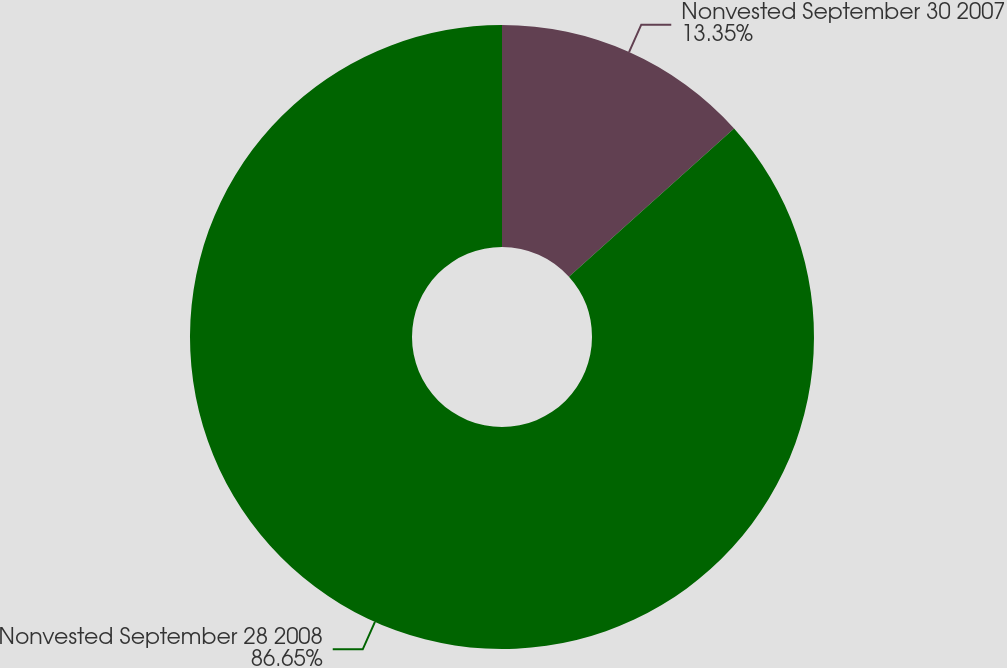Convert chart to OTSL. <chart><loc_0><loc_0><loc_500><loc_500><pie_chart><fcel>Nonvested September 30 2007<fcel>Nonvested September 28 2008<nl><fcel>13.35%<fcel>86.65%<nl></chart> 